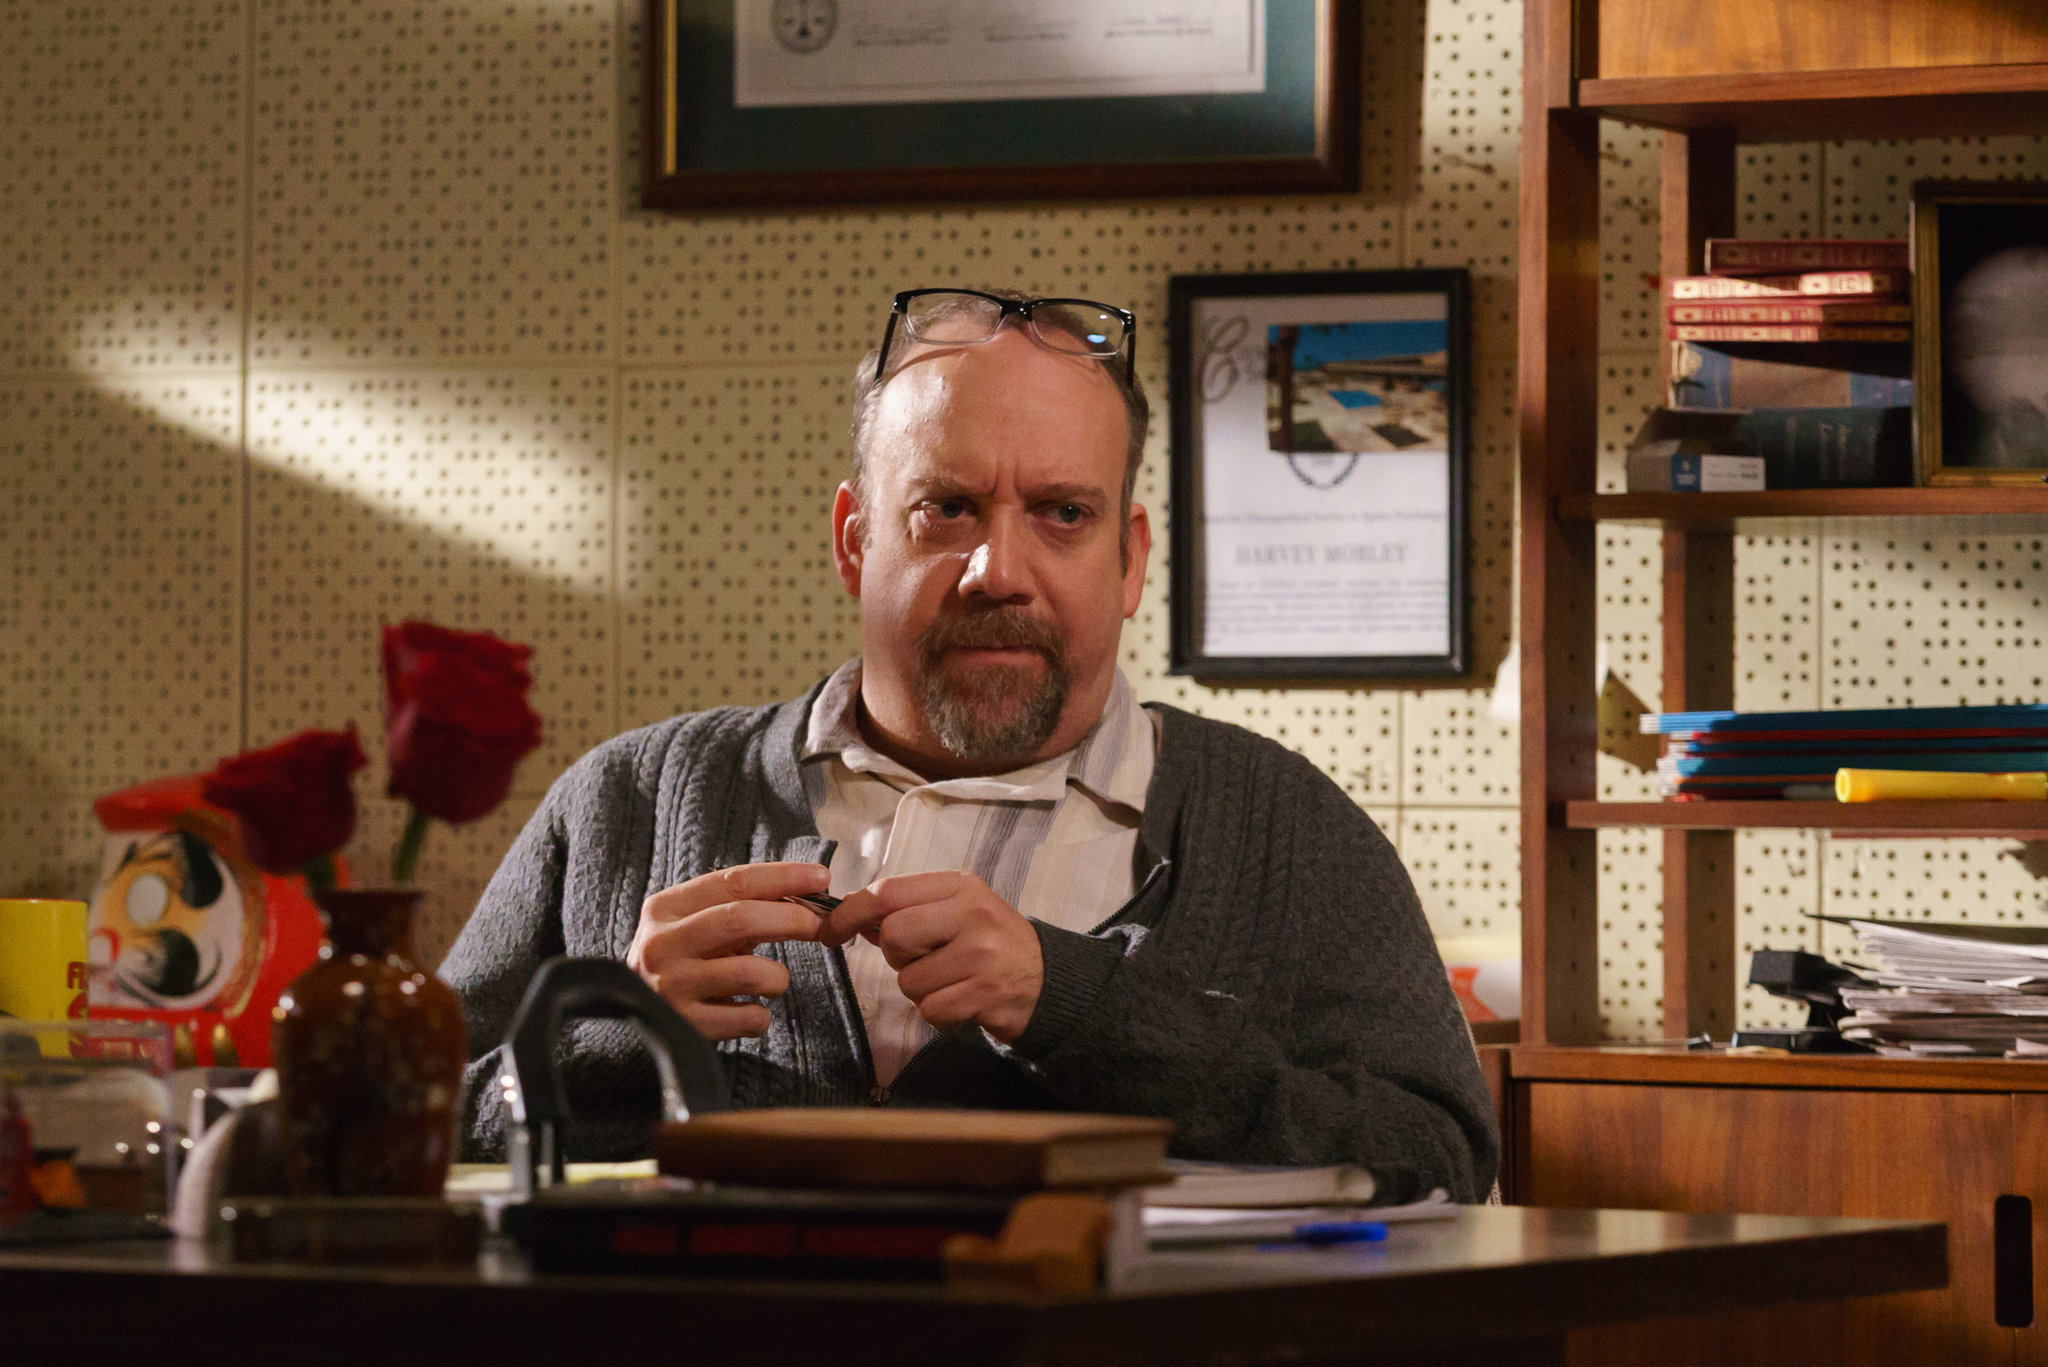Write a detailed description of the given image. In the image, we see a man deeply engrossed in thought, seated at a desk within an office that exudes an aura of organized chaos. The desk is a whirlwind of activity with books and papers strewn about, indicating a busy and perhaps creative work environment. A coffee mug sits among the items, perhaps a companion through extensive hours of work.

The man, dressed in a layered outfit with a gray sweater over a white collared shirt, holds a pen in his right hand, suggesting he was in the midst of writing or reviewing documents. His glasses rest on his head, hinting that he's taken a brief pause from reading or writing. His expression is serious, with a look of intense concentration directed towards the camera, capturing a moment of deep thought.

The warm hues of brown and orange that dominate the scene enhance the intense atmosphere. In the background, a bookshelf crammed with books and a framed picture on the wall further enrich the setting, adding layers to the narrative of a dedicated, hardworking individual deeply absorbed in his endeavors. 